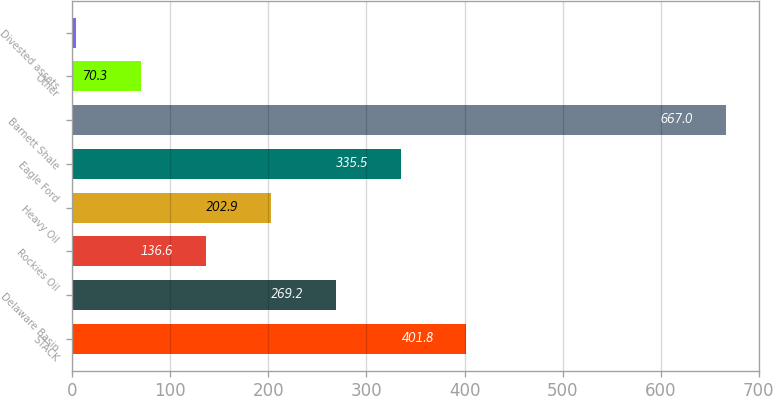Convert chart. <chart><loc_0><loc_0><loc_500><loc_500><bar_chart><fcel>STACK<fcel>Delaware Basin<fcel>Rockies Oil<fcel>Heavy Oil<fcel>Eagle Ford<fcel>Barnett Shale<fcel>Other<fcel>Divested assets<nl><fcel>401.8<fcel>269.2<fcel>136.6<fcel>202.9<fcel>335.5<fcel>667<fcel>70.3<fcel>4<nl></chart> 